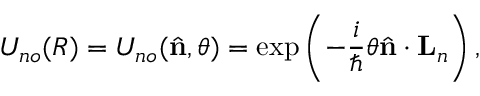Convert formula to latex. <formula><loc_0><loc_0><loc_500><loc_500>U _ { n o } ( R ) = U _ { n o } ( { \hat { n } } , \theta ) = \exp \left ( - \frac { i } { } \theta { \hat { n } } \cdot { L } _ { n } \right ) ,</formula> 